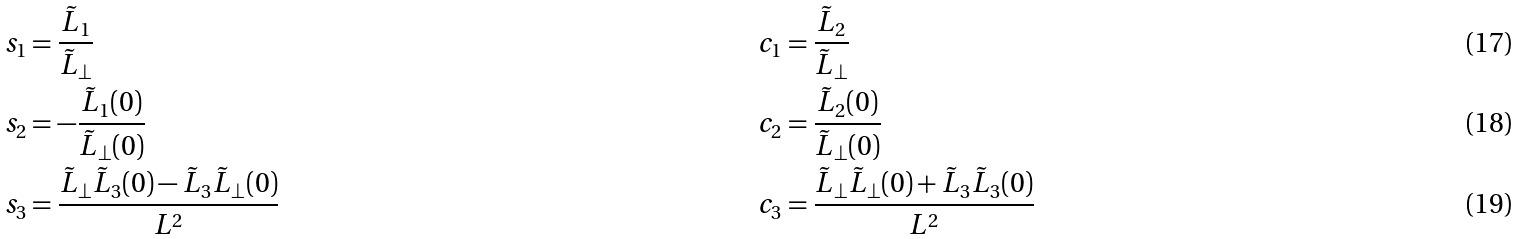<formula> <loc_0><loc_0><loc_500><loc_500>s _ { 1 } & = \frac { \tilde { L } _ { 1 } } { \tilde { L } _ { \perp } } & c _ { 1 } & = \frac { \tilde { L } _ { 2 } } { \tilde { L } _ { \perp } } \\ s _ { 2 } & = - \frac { \tilde { L } _ { 1 } ( 0 ) } { \tilde { L } _ { \perp } ( 0 ) } & c _ { 2 } & = \frac { \tilde { L } _ { 2 } ( 0 ) } { \tilde { L } _ { \perp } ( 0 ) } \\ s _ { 3 } & = \frac { \tilde { L } _ { \perp } \tilde { L } _ { 3 } ( 0 ) - \tilde { L } _ { 3 } \tilde { L } _ { \perp } ( 0 ) } { L ^ { 2 } } & c _ { 3 } & = \frac { \tilde { L } _ { \perp } \tilde { L } _ { \perp } ( 0 ) + \tilde { L } _ { 3 } \tilde { L } _ { 3 } ( 0 ) } { L ^ { 2 } }</formula> 